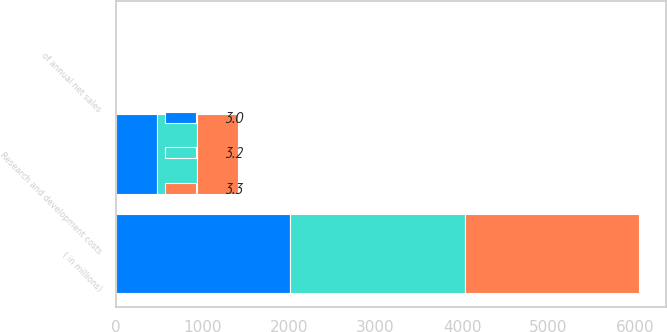Convert chart to OTSL. <chart><loc_0><loc_0><loc_500><loc_500><stacked_bar_chart><ecel><fcel>( in millions)<fcel>Research and development costs<fcel>of annual net sales<nl><fcel>3.2<fcel>2018<fcel>464<fcel>3<nl><fcel>3.3<fcel>2017<fcel>472<fcel>3.2<nl><fcel>3<fcel>2016<fcel>473<fcel>3.3<nl></chart> 